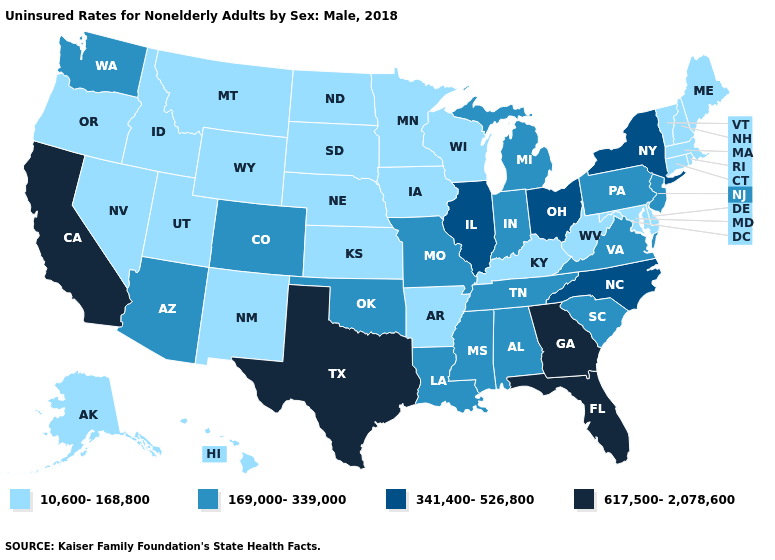Name the states that have a value in the range 617,500-2,078,600?
Write a very short answer. California, Florida, Georgia, Texas. Does Iowa have the highest value in the USA?
Give a very brief answer. No. Name the states that have a value in the range 341,400-526,800?
Quick response, please. Illinois, New York, North Carolina, Ohio. What is the lowest value in the MidWest?
Concise answer only. 10,600-168,800. Name the states that have a value in the range 10,600-168,800?
Keep it brief. Alaska, Arkansas, Connecticut, Delaware, Hawaii, Idaho, Iowa, Kansas, Kentucky, Maine, Maryland, Massachusetts, Minnesota, Montana, Nebraska, Nevada, New Hampshire, New Mexico, North Dakota, Oregon, Rhode Island, South Dakota, Utah, Vermont, West Virginia, Wisconsin, Wyoming. Does Missouri have the lowest value in the USA?
Be succinct. No. Name the states that have a value in the range 617,500-2,078,600?
Quick response, please. California, Florida, Georgia, Texas. Name the states that have a value in the range 10,600-168,800?
Write a very short answer. Alaska, Arkansas, Connecticut, Delaware, Hawaii, Idaho, Iowa, Kansas, Kentucky, Maine, Maryland, Massachusetts, Minnesota, Montana, Nebraska, Nevada, New Hampshire, New Mexico, North Dakota, Oregon, Rhode Island, South Dakota, Utah, Vermont, West Virginia, Wisconsin, Wyoming. Name the states that have a value in the range 10,600-168,800?
Keep it brief. Alaska, Arkansas, Connecticut, Delaware, Hawaii, Idaho, Iowa, Kansas, Kentucky, Maine, Maryland, Massachusetts, Minnesota, Montana, Nebraska, Nevada, New Hampshire, New Mexico, North Dakota, Oregon, Rhode Island, South Dakota, Utah, Vermont, West Virginia, Wisconsin, Wyoming. Does the first symbol in the legend represent the smallest category?
Short answer required. Yes. What is the lowest value in the USA?
Be succinct. 10,600-168,800. What is the lowest value in states that border Illinois?
Concise answer only. 10,600-168,800. Which states have the highest value in the USA?
Be succinct. California, Florida, Georgia, Texas. Does the map have missing data?
Write a very short answer. No. What is the value of Alabama?
Quick response, please. 169,000-339,000. 